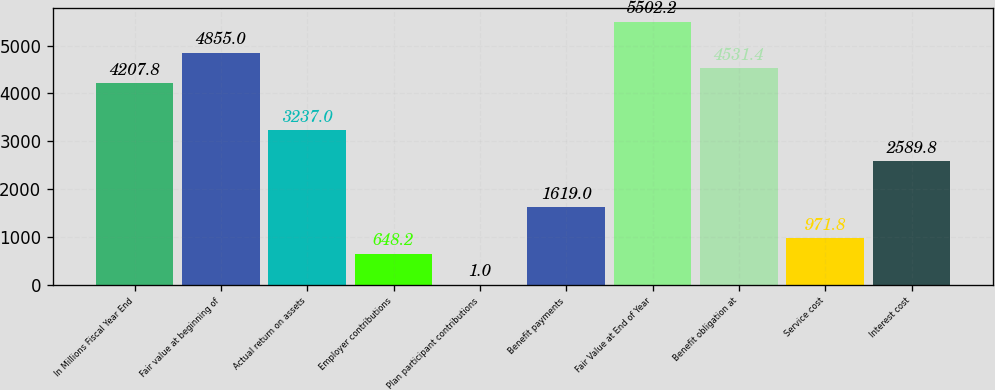<chart> <loc_0><loc_0><loc_500><loc_500><bar_chart><fcel>In Millions Fiscal Year End<fcel>Fair value at beginning of<fcel>Actual return on assets<fcel>Employer contributions<fcel>Plan participant contributions<fcel>Benefit payments<fcel>Fair Value at End of Year<fcel>Benefit obligation at<fcel>Service cost<fcel>Interest cost<nl><fcel>4207.8<fcel>4855<fcel>3237<fcel>648.2<fcel>1<fcel>1619<fcel>5502.2<fcel>4531.4<fcel>971.8<fcel>2589.8<nl></chart> 